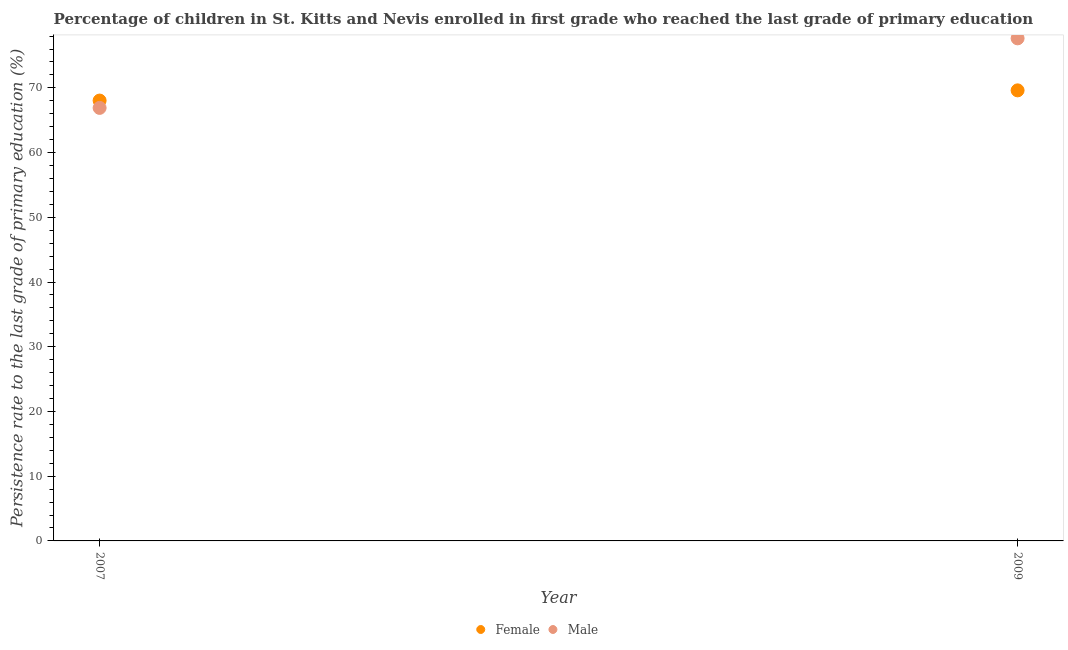How many different coloured dotlines are there?
Your answer should be very brief. 2. Is the number of dotlines equal to the number of legend labels?
Keep it short and to the point. Yes. What is the persistence rate of female students in 2007?
Keep it short and to the point. 68.04. Across all years, what is the maximum persistence rate of female students?
Make the answer very short. 69.61. Across all years, what is the minimum persistence rate of male students?
Offer a very short reply. 66.9. In which year was the persistence rate of male students maximum?
Your response must be concise. 2009. What is the total persistence rate of female students in the graph?
Offer a terse response. 137.65. What is the difference between the persistence rate of female students in 2007 and that in 2009?
Your answer should be compact. -1.58. What is the difference between the persistence rate of female students in 2007 and the persistence rate of male students in 2009?
Ensure brevity in your answer.  -9.61. What is the average persistence rate of female students per year?
Your response must be concise. 68.82. In the year 2009, what is the difference between the persistence rate of male students and persistence rate of female students?
Keep it short and to the point. 8.04. What is the ratio of the persistence rate of male students in 2007 to that in 2009?
Provide a succinct answer. 0.86. Is the persistence rate of male students strictly greater than the persistence rate of female students over the years?
Keep it short and to the point. No. What is the difference between two consecutive major ticks on the Y-axis?
Your answer should be very brief. 10. Are the values on the major ticks of Y-axis written in scientific E-notation?
Your response must be concise. No. Does the graph contain any zero values?
Your answer should be compact. No. Does the graph contain grids?
Your answer should be compact. No. Where does the legend appear in the graph?
Make the answer very short. Bottom center. What is the title of the graph?
Offer a very short reply. Percentage of children in St. Kitts and Nevis enrolled in first grade who reached the last grade of primary education. Does "Goods" appear as one of the legend labels in the graph?
Provide a short and direct response. No. What is the label or title of the X-axis?
Keep it short and to the point. Year. What is the label or title of the Y-axis?
Give a very brief answer. Persistence rate to the last grade of primary education (%). What is the Persistence rate to the last grade of primary education (%) of Female in 2007?
Make the answer very short. 68.04. What is the Persistence rate to the last grade of primary education (%) of Male in 2007?
Your answer should be compact. 66.9. What is the Persistence rate to the last grade of primary education (%) of Female in 2009?
Your response must be concise. 69.61. What is the Persistence rate to the last grade of primary education (%) of Male in 2009?
Your answer should be very brief. 77.65. Across all years, what is the maximum Persistence rate to the last grade of primary education (%) of Female?
Provide a short and direct response. 69.61. Across all years, what is the maximum Persistence rate to the last grade of primary education (%) of Male?
Keep it short and to the point. 77.65. Across all years, what is the minimum Persistence rate to the last grade of primary education (%) of Female?
Your answer should be compact. 68.04. Across all years, what is the minimum Persistence rate to the last grade of primary education (%) of Male?
Your answer should be compact. 66.9. What is the total Persistence rate to the last grade of primary education (%) of Female in the graph?
Provide a succinct answer. 137.65. What is the total Persistence rate to the last grade of primary education (%) in Male in the graph?
Provide a short and direct response. 144.55. What is the difference between the Persistence rate to the last grade of primary education (%) of Female in 2007 and that in 2009?
Provide a succinct answer. -1.58. What is the difference between the Persistence rate to the last grade of primary education (%) in Male in 2007 and that in 2009?
Offer a terse response. -10.74. What is the difference between the Persistence rate to the last grade of primary education (%) in Female in 2007 and the Persistence rate to the last grade of primary education (%) in Male in 2009?
Ensure brevity in your answer.  -9.61. What is the average Persistence rate to the last grade of primary education (%) of Female per year?
Offer a terse response. 68.82. What is the average Persistence rate to the last grade of primary education (%) of Male per year?
Keep it short and to the point. 72.28. In the year 2007, what is the difference between the Persistence rate to the last grade of primary education (%) in Female and Persistence rate to the last grade of primary education (%) in Male?
Give a very brief answer. 1.13. In the year 2009, what is the difference between the Persistence rate to the last grade of primary education (%) in Female and Persistence rate to the last grade of primary education (%) in Male?
Keep it short and to the point. -8.04. What is the ratio of the Persistence rate to the last grade of primary education (%) in Female in 2007 to that in 2009?
Your answer should be compact. 0.98. What is the ratio of the Persistence rate to the last grade of primary education (%) of Male in 2007 to that in 2009?
Provide a succinct answer. 0.86. What is the difference between the highest and the second highest Persistence rate to the last grade of primary education (%) of Female?
Provide a short and direct response. 1.58. What is the difference between the highest and the second highest Persistence rate to the last grade of primary education (%) in Male?
Offer a very short reply. 10.74. What is the difference between the highest and the lowest Persistence rate to the last grade of primary education (%) of Female?
Give a very brief answer. 1.58. What is the difference between the highest and the lowest Persistence rate to the last grade of primary education (%) of Male?
Give a very brief answer. 10.74. 